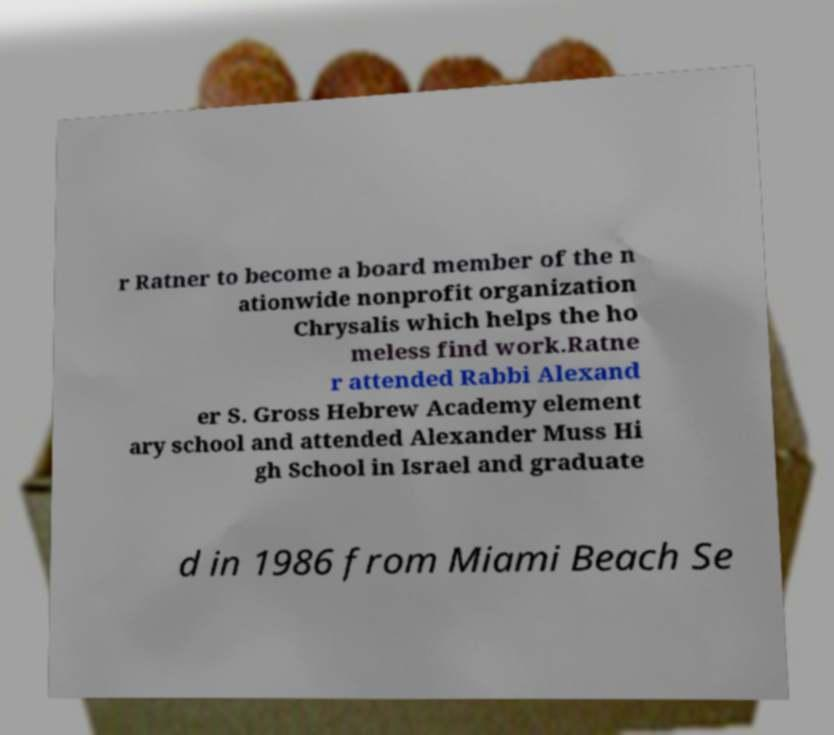Could you assist in decoding the text presented in this image and type it out clearly? r Ratner to become a board member of the n ationwide nonprofit organization Chrysalis which helps the ho meless find work.Ratne r attended Rabbi Alexand er S. Gross Hebrew Academy element ary school and attended Alexander Muss Hi gh School in Israel and graduate d in 1986 from Miami Beach Se 